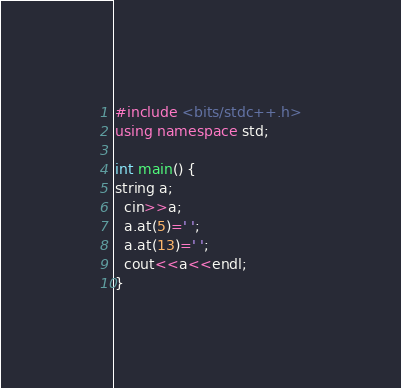Convert code to text. <code><loc_0><loc_0><loc_500><loc_500><_C++_>#include <bits/stdc++.h>
using namespace std;
 
int main() {
string a;
  cin>>a;
  a.at(5)=' ';
  a.at(13)=' ';
  cout<<a<<endl;
}</code> 